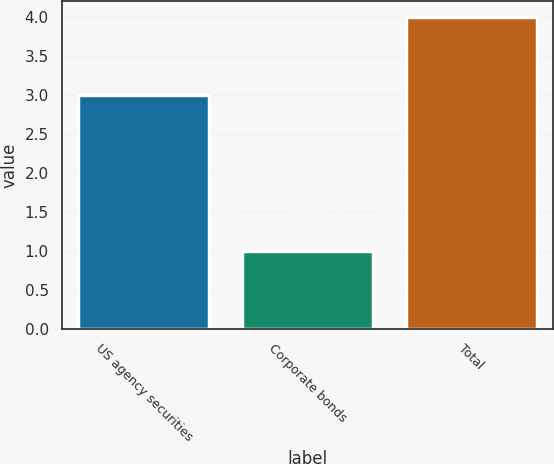Convert chart to OTSL. <chart><loc_0><loc_0><loc_500><loc_500><bar_chart><fcel>US agency securities<fcel>Corporate bonds<fcel>Total<nl><fcel>3<fcel>1<fcel>4<nl></chart> 